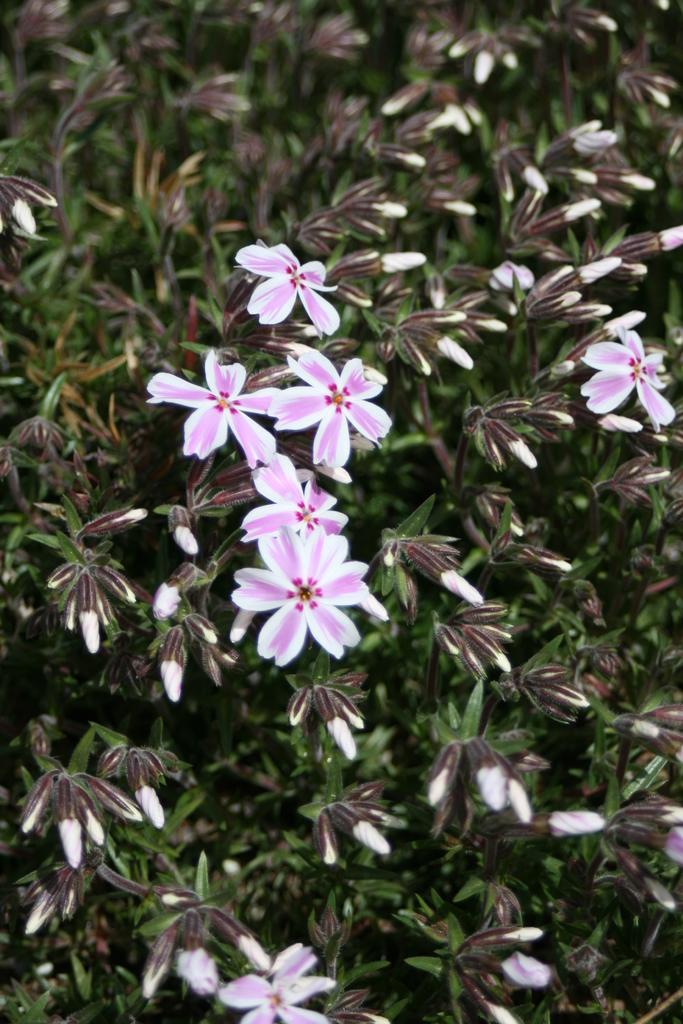What type of plant material can be seen in the image? There are leaves and flowers in the image. Can you describe the flowers in the image? Unfortunately, the facts provided do not give any details about the flowers, so we cannot describe them. What type of angle is being used to take the picture of the advertisement in the image? There is no advertisement present in the image, so we cannot determine the angle used to take the picture. 